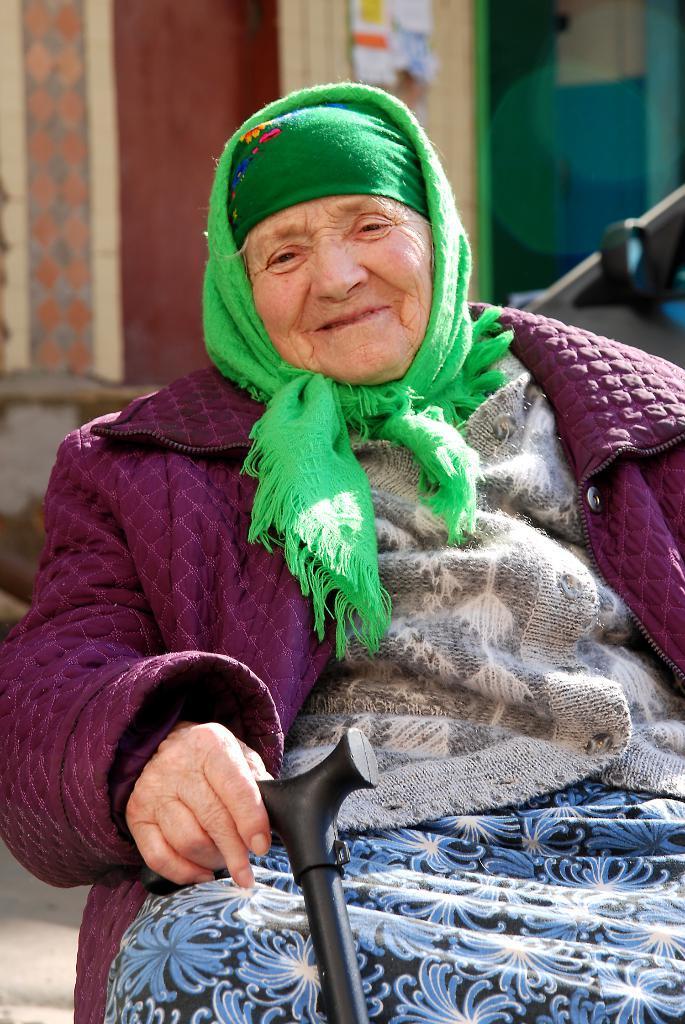Please provide a concise description of this image. In this image we can see a woman wearing dress and cap is holding a stick in her hand. In the background, we can see a building and a vehicle. 